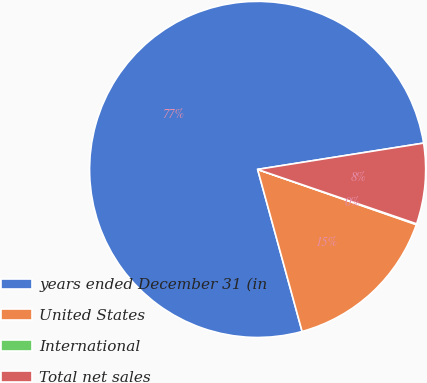Convert chart to OTSL. <chart><loc_0><loc_0><loc_500><loc_500><pie_chart><fcel>years ended December 31 (in<fcel>United States<fcel>International<fcel>Total net sales<nl><fcel>76.76%<fcel>15.41%<fcel>0.08%<fcel>7.75%<nl></chart> 